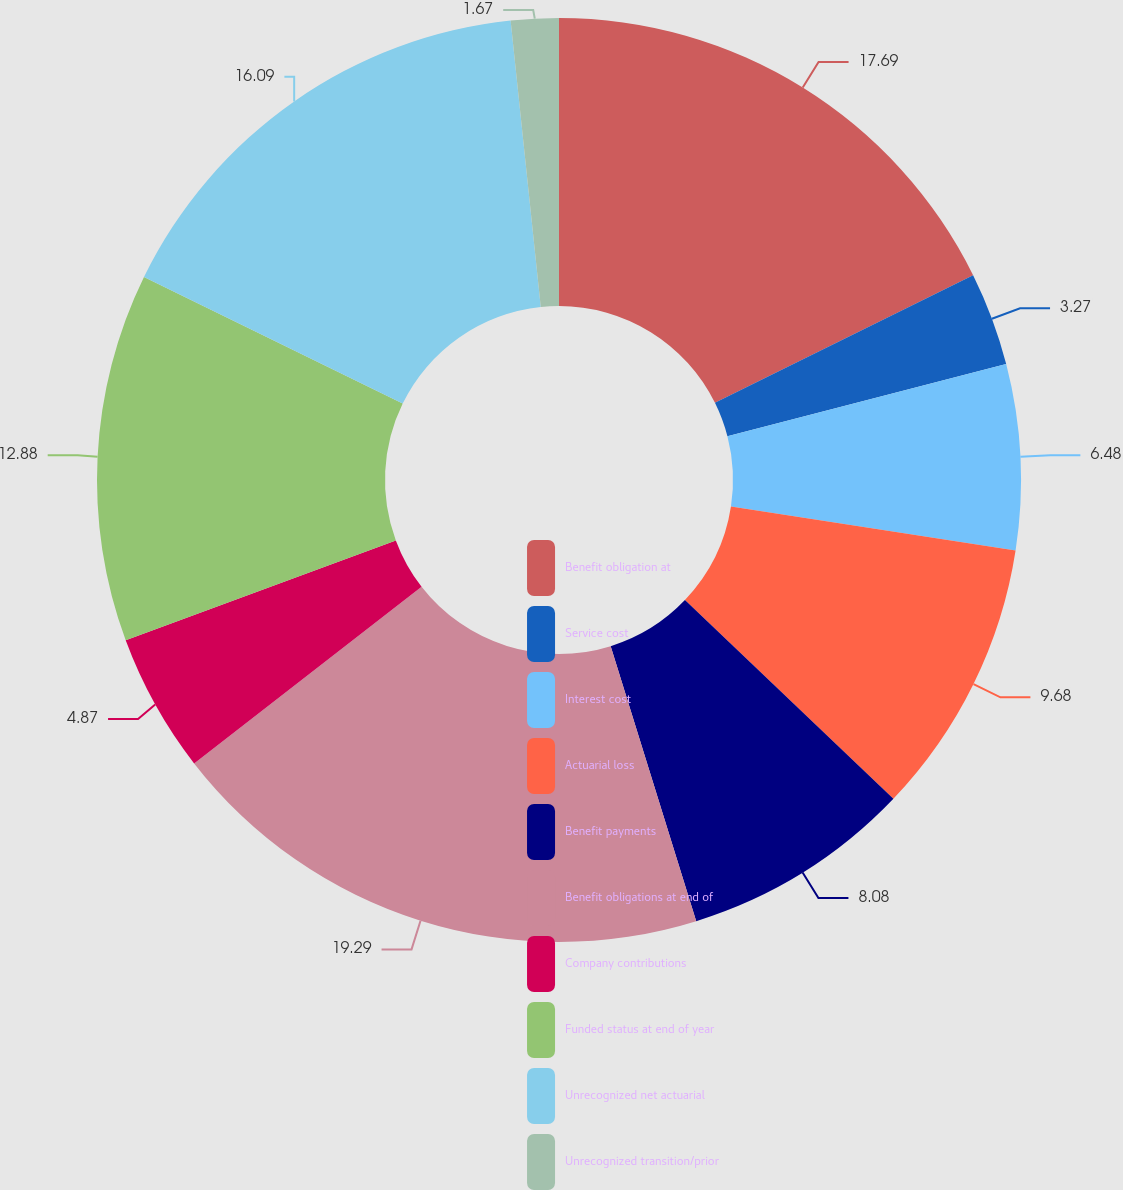Convert chart. <chart><loc_0><loc_0><loc_500><loc_500><pie_chart><fcel>Benefit obligation at<fcel>Service cost<fcel>Interest cost<fcel>Actuarial loss<fcel>Benefit payments<fcel>Benefit obligations at end of<fcel>Company contributions<fcel>Funded status at end of year<fcel>Unrecognized net actuarial<fcel>Unrecognized transition/prior<nl><fcel>17.69%<fcel>3.27%<fcel>6.48%<fcel>9.68%<fcel>8.08%<fcel>19.29%<fcel>4.87%<fcel>12.88%<fcel>16.09%<fcel>1.67%<nl></chart> 